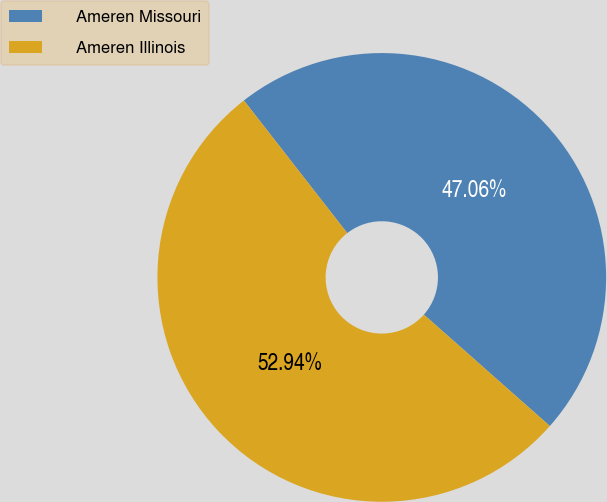Convert chart. <chart><loc_0><loc_0><loc_500><loc_500><pie_chart><fcel>Ameren Missouri<fcel>Ameren Illinois<nl><fcel>47.06%<fcel>52.94%<nl></chart> 